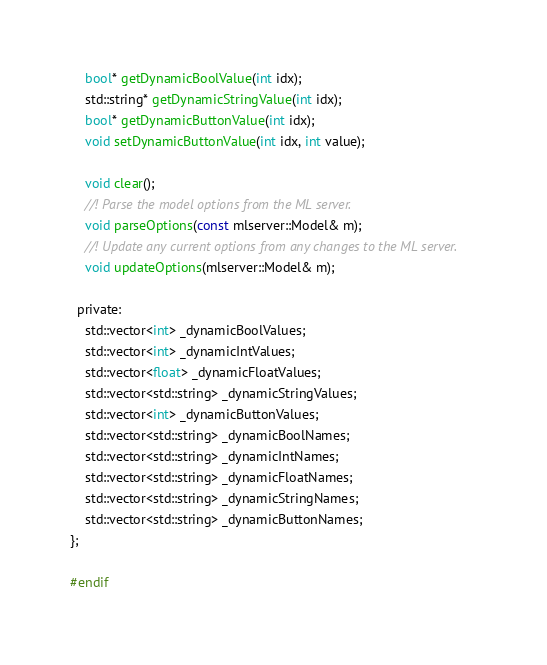<code> <loc_0><loc_0><loc_500><loc_500><_C_>    bool* getDynamicBoolValue(int idx);
    std::string* getDynamicStringValue(int idx);
    bool* getDynamicButtonValue(int idx);
    void setDynamicButtonValue(int idx, int value);

    void clear();
    //! Parse the model options from the ML server.
    void parseOptions(const mlserver::Model& m);
    //! Update any current options from any changes to the ML server.
    void updateOptions(mlserver::Model& m);

  private:
    std::vector<int> _dynamicBoolValues;
    std::vector<int> _dynamicIntValues;
    std::vector<float> _dynamicFloatValues;
    std::vector<std::string> _dynamicStringValues;
    std::vector<int> _dynamicButtonValues;
    std::vector<std::string> _dynamicBoolNames;
    std::vector<std::string> _dynamicIntNames;
    std::vector<std::string> _dynamicFloatNames;
    std::vector<std::string> _dynamicStringNames;
    std::vector<std::string> _dynamicButtonNames;
};

#endif
</code> 